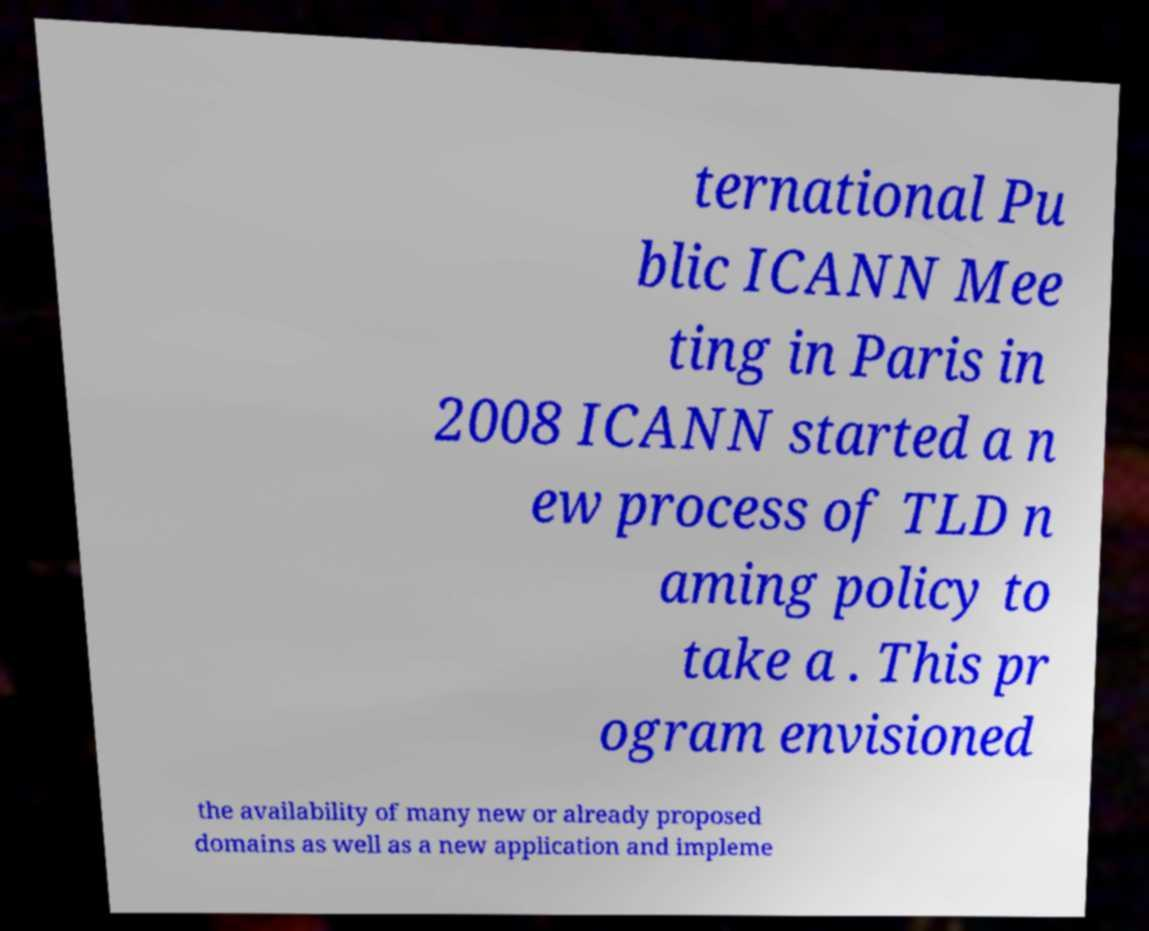Could you assist in decoding the text presented in this image and type it out clearly? ternational Pu blic ICANN Mee ting in Paris in 2008 ICANN started a n ew process of TLD n aming policy to take a . This pr ogram envisioned the availability of many new or already proposed domains as well as a new application and impleme 